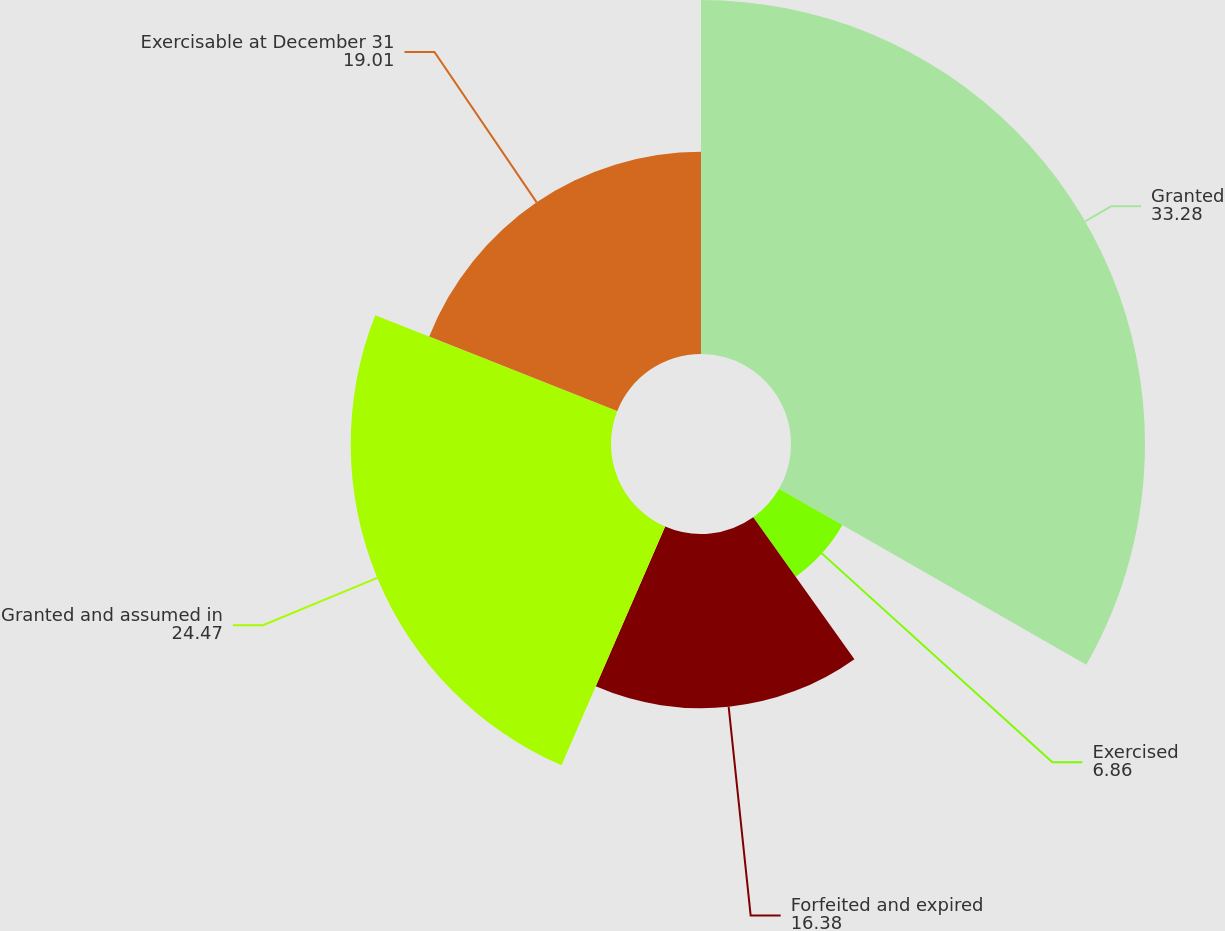<chart> <loc_0><loc_0><loc_500><loc_500><pie_chart><fcel>Granted<fcel>Exercised<fcel>Forfeited and expired<fcel>Granted and assumed in<fcel>Exercisable at December 31<nl><fcel>33.28%<fcel>6.86%<fcel>16.38%<fcel>24.47%<fcel>19.01%<nl></chart> 